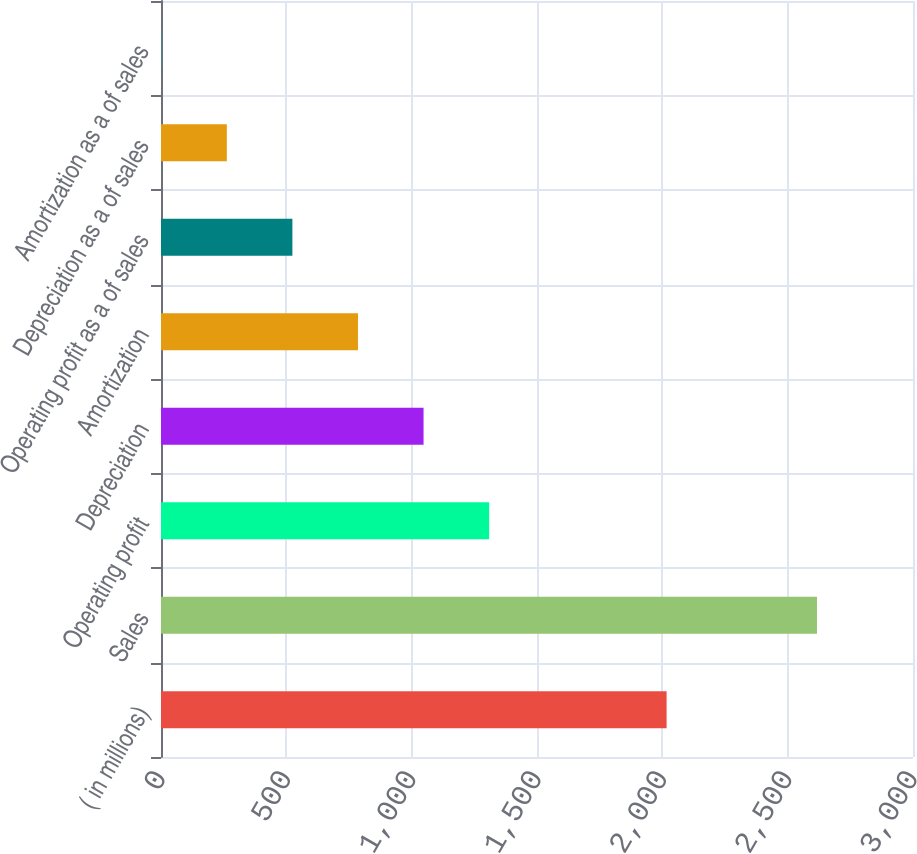Convert chart to OTSL. <chart><loc_0><loc_0><loc_500><loc_500><bar_chart><fcel>( in millions)<fcel>Sales<fcel>Operating profit<fcel>Depreciation<fcel>Amortization<fcel>Operating profit as a of sales<fcel>Depreciation as a of sales<fcel>Amortization as a of sales<nl><fcel>2017<fcel>2617<fcel>1309<fcel>1047.4<fcel>785.8<fcel>524.2<fcel>262.6<fcel>1<nl></chart> 